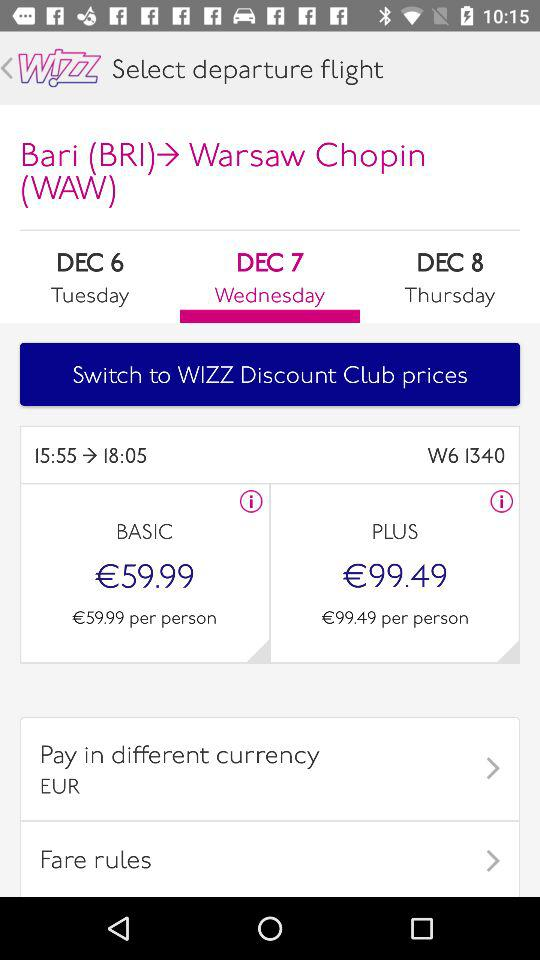What is the price of the flight ticket in the "BASIC" category? The price of the flight ticket is €59.99. 